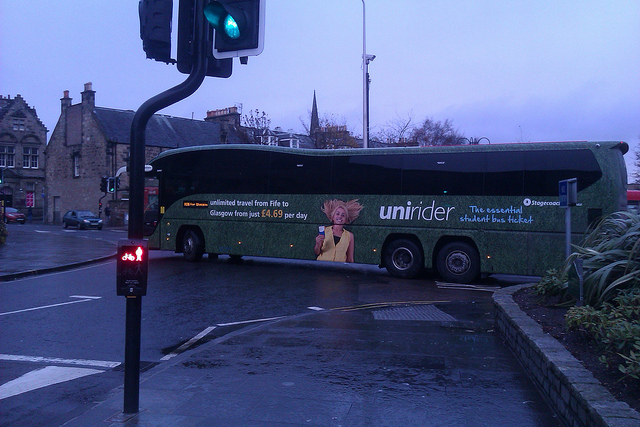Is there anything unusual or out of place in this image? The image captures a typical urban scene featuring vehicles, a pedestrian traffic light, and surrounding buildings. Nothing appears unusual or out of place, and everything seems consistent with an everyday urban environment. 